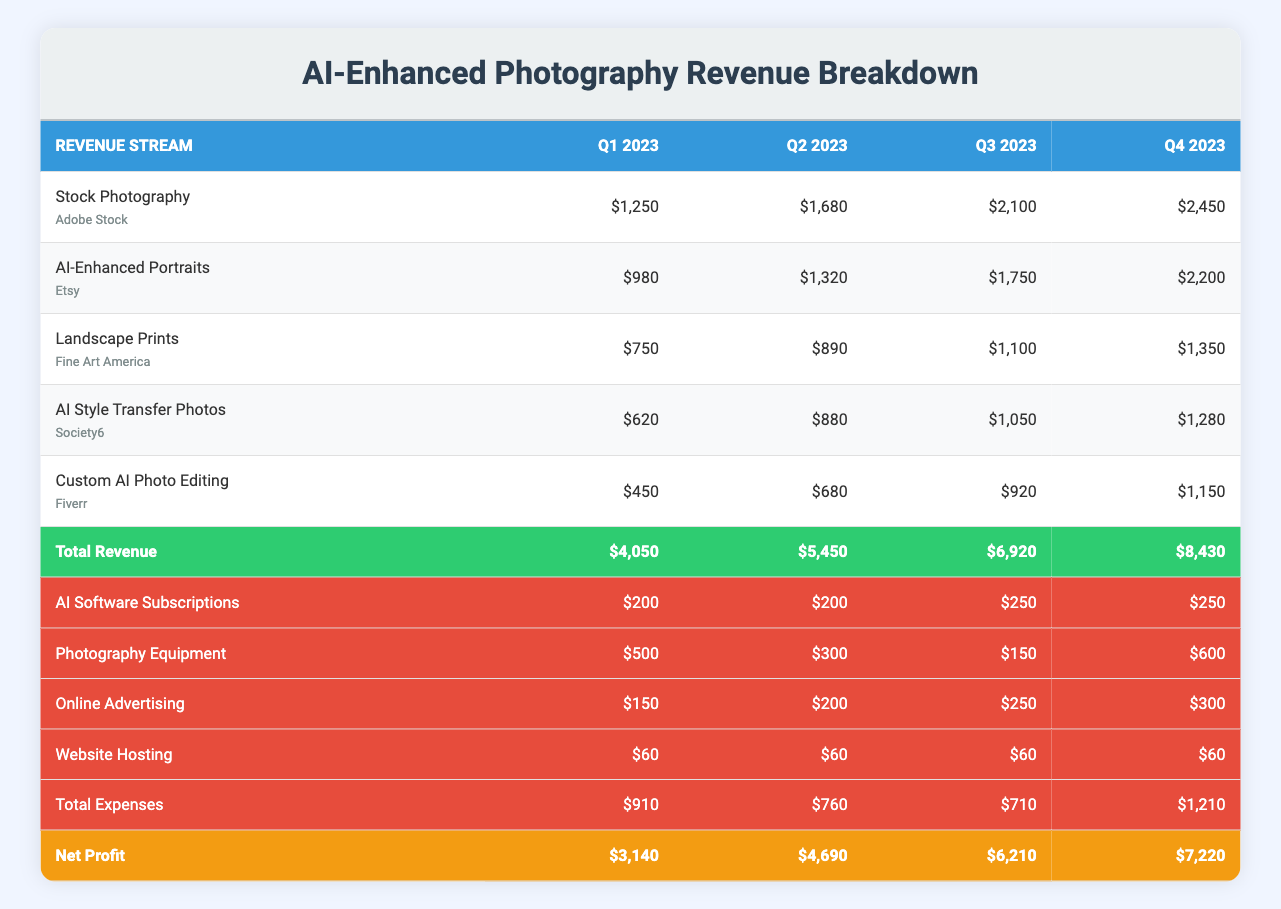What was the net profit for Q3 2023? The net profit for Q3 2023 is found in the corresponding row under the "Net Profit" section. It states $6,210.
Answer: 6,210 What is the total revenue for Q2 2023? The total revenue for Q2 2023 is located in the "Total Revenue" row. The value for Q2 is $5,450.
Answer: 5,450 Which revenue stream earned the highest amount in Q4 2023? In Q4 2023, the revenue streams and their amounts must be compared. Stock Photography has the highest revenue at $2,450.
Answer: Stock Photography What is the average quarterly revenue from AI-Enhanced Portraits across all quarters? The quarterly revenues for AI-Enhanced Portraits are $980, $1,320, $1,750, and $2,200. Summing these gives a total of $6,250. Dividing by 4 (number of quarters) gives the average revenue: $6,250 / 4 = $1,562.50.
Answer: 1,562.50 Did the expenses decrease from Q1 to Q2 2023? To determine this, compare the total expenses for Q1 and Q2. For Q1, the expenses are $910 and for Q2 they are $760. Since $910 is greater than $760, expenses did decrease.
Answer: Yes What is the total profit increase from Q1 to Q4 2023? The net profit for Q1 2023 is $3,140 and for Q4 2023 is $7,220. The increase is calculated as $7,220 - $3,140 = $4,080.
Answer: 4,080 What's the total expense on Photography Equipment for 2023? Summing the quarterly expenses for Photography Equipment gives $500 (Q1) + $300 (Q2) + $150 (Q3) + $600 (Q4) = $1,550.
Answer: 1,550 Was the revenue from AI Style Transfer Photos in Q3 greater than the total expenses for that quarter? The revenue for AI Style Transfer Photos in Q3 is $1,050, and the total expenses for Q3 is $710. Since $1,050 > $710, the statement is true.
Answer: Yes What was the expense on Online Advertising in Q1 2023? The expense for Online Advertising for Q1 2023 is indicated in the table as $150.
Answer: 150 